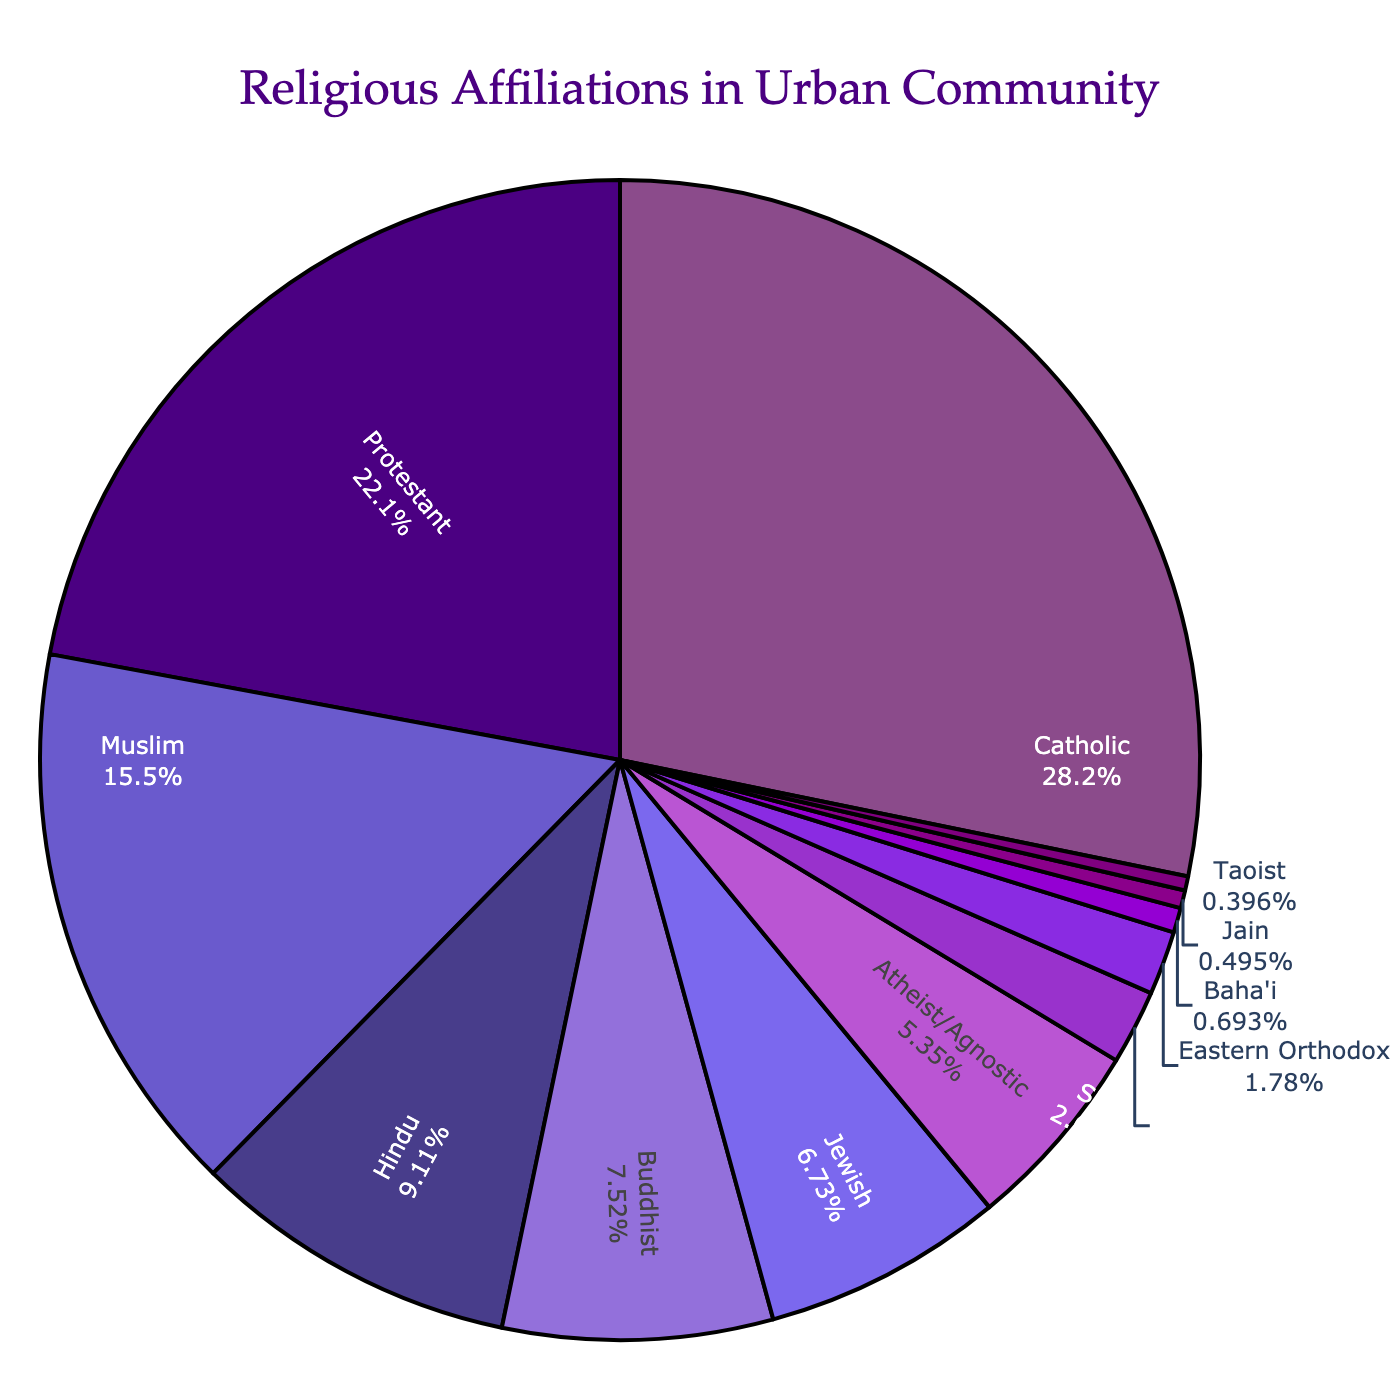What's the largest percentage among the religious affiliations? The figure shows a pie chart with different percentages for each religious affiliation. By visually inspecting the slices, the largest one corresponds to the Catholic affiliation, which is labeled with 28.5%.
Answer: 28.5% Which two religious groups have percentages that sum up to more than 50%? To find the two religious groups whose percentages add up to more than 50%, we can start by looking at the largest slices. Catholic (28.5%) and Protestant (22.3%) together sum up to 50.8%, which is more than 50%.
Answer: Catholic and Protestant What is the least represented religious affiliation? By examining the smallest slices on the pie chart, we find that the Taoist group has the smallest percentage, which is labeled as 0.4%.
Answer: Taoist How much larger is the Protestant group compared to the Buddhist group in percentage terms? The Protestant group is labeled as 22.3%, while the Buddhist group is labeled as 7.6%. Subtracting these gives 22.3% - 7.6% = 14.7%.
Answer: 14.7% Which religious group is just larger than the Jewish group? By looking at the neighboring slices, the Jewish group is labeled as 6.8%. The next larger group is the Buddhist group, which is labeled as 7.6%.
Answer: Buddhist What's the combined percentage of the Hindu and Muslim communities? The Hindu community is labeled as 9.2%, and the Muslim community is labeled as 15.7%. Adding these together gives 9.2% + 15.7% = 24.9%.
Answer: 24.9% Among the religious affiliations that are below 10%, which three have the highest percentages? Looking at all affiliations below 10%, we find Hindu (9.2%), Buddhist (7.6%), and Jewish (6.8%). These are the highest among this group.
Answer: Hindu, Buddhist, and Jewish How does the percentage of Eastern Orthodox compare to that of Sikh? The Eastern Orthodox group is labeled as 1.8%, while the Sikh group is labeled as 2.1%. Thus, the Sikh group has a slightly larger percentage than the Eastern Orthodox group.
Answer: Sikh has a larger percentage If an individual is chosen at random from this community, what is the probability (in percentage) that the person is either Atheist/Agnostic or Sikh? The Atheist/Agnostic group is labeled as 5.4%, and the Sikh group is labeled as 2.1%. Adding these together gives 5.4% + 2.1% = 7.5%.
Answer: 7.5% What is the difference in percentage between the Catholic and the Muslim communities? The Catholic community is labeled as 28.5%, and the Muslim community is labeled as 15.7%. Subtracting these, we get 28.5% - 15.7% = 12.8%.
Answer: 12.8% 